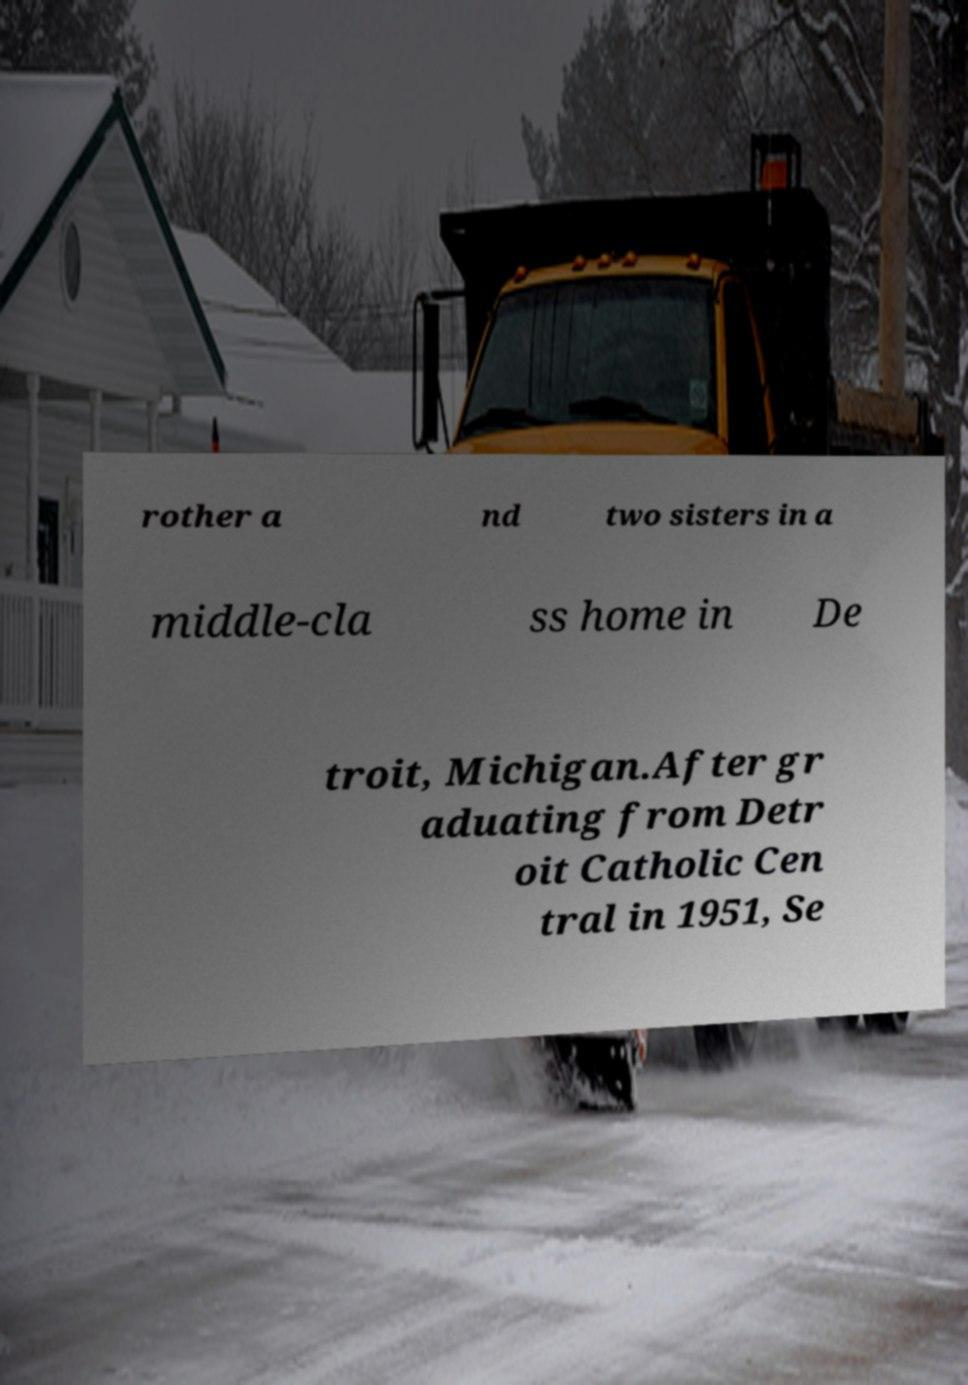Could you assist in decoding the text presented in this image and type it out clearly? rother a nd two sisters in a middle-cla ss home in De troit, Michigan.After gr aduating from Detr oit Catholic Cen tral in 1951, Se 